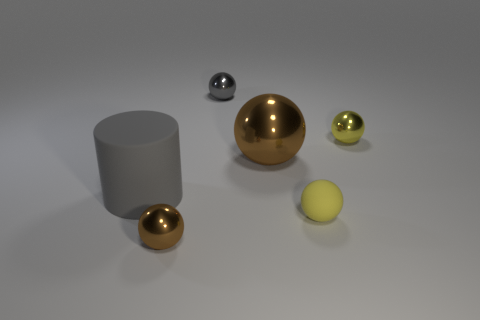Are there any purple things?
Keep it short and to the point. No. What number of tiny metallic balls have the same color as the large cylinder?
Provide a succinct answer. 1. Is the material of the large gray cylinder the same as the gray thing right of the tiny brown sphere?
Offer a terse response. No. Is the number of tiny metal balls that are in front of the yellow rubber object greater than the number of tiny cyan metal cubes?
Your response must be concise. Yes. There is a small matte sphere; is its color the same as the metal object right of the big brown metal object?
Make the answer very short. Yes. Is the number of gray shiny spheres in front of the big brown metal object the same as the number of tiny gray balls that are in front of the gray metal ball?
Keep it short and to the point. Yes. What is the yellow ball that is in front of the big metal sphere made of?
Keep it short and to the point. Rubber. What number of objects are either metallic objects that are to the right of the big gray rubber cylinder or brown metallic blocks?
Make the answer very short. 4. How many other objects are the same shape as the big metallic thing?
Make the answer very short. 4. Is the shape of the shiny object to the right of the large brown metal thing the same as  the tiny brown thing?
Offer a terse response. Yes. 